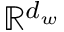Convert formula to latex. <formula><loc_0><loc_0><loc_500><loc_500>\mathbb { R } ^ { d _ { w } }</formula> 